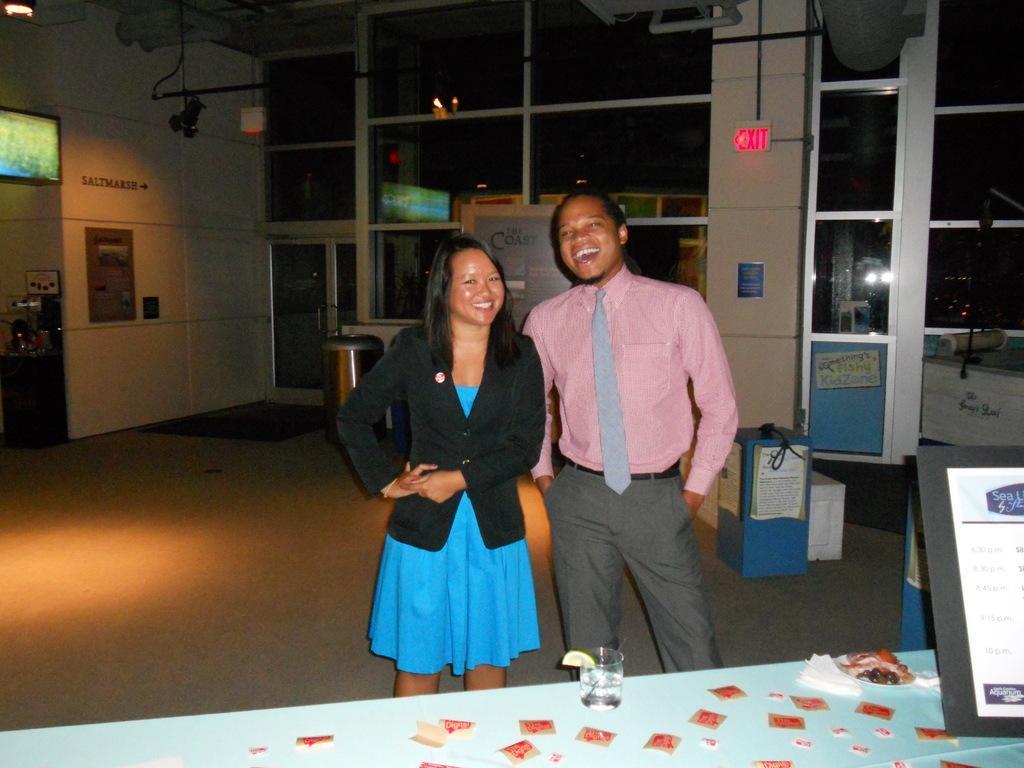Can you describe this image briefly? There is a woman and man at the table. On the table we can see a glass and a frame. In the background there are doors,TV,boxes,door and dustbin. 